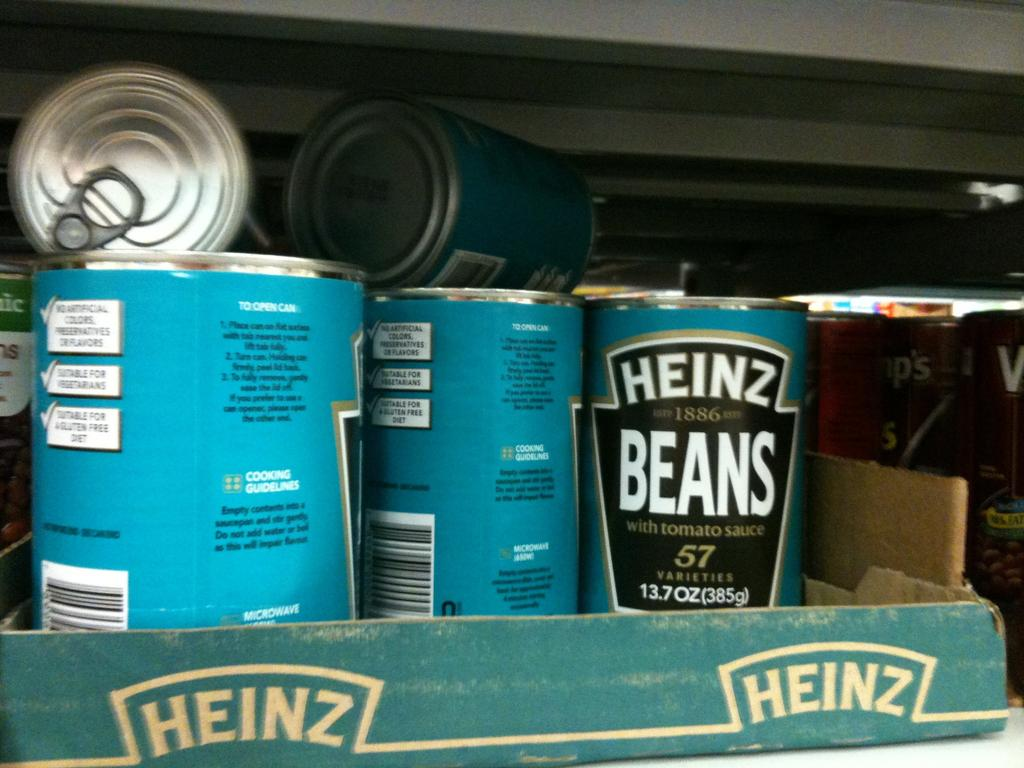What objects are present in the image? There are tins in the image. Where are the tins located? The tins are in a cardboard box. What color are the tins? The tins are blue in color. What type of bomb is hidden in the cardboard box in the image? There is no bomb present in the image; it only contains tins. 